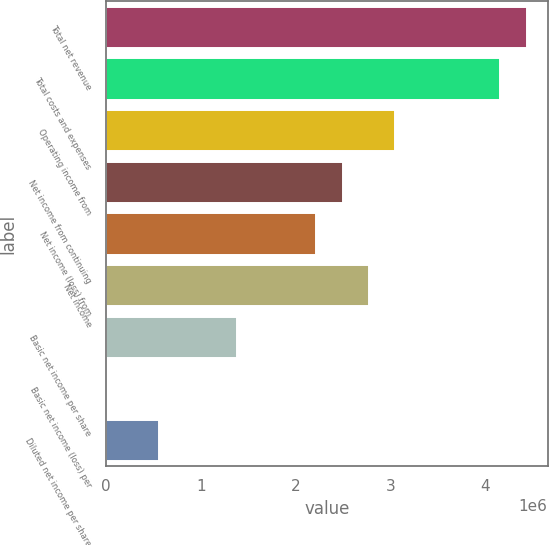Convert chart. <chart><loc_0><loc_0><loc_500><loc_500><bar_chart><fcel>Total net revenue<fcel>Total costs and expenses<fcel>Operating income from<fcel>Net income from continuing<fcel>Net income (loss) from<fcel>Net income<fcel>Basic net income per share<fcel>Basic net income (loss) per<fcel>Diluted net income per share<nl><fcel>4.43204e+06<fcel>4.15504e+06<fcel>3.04703e+06<fcel>2.49302e+06<fcel>2.21602e+06<fcel>2.77003e+06<fcel>1.38501e+06<fcel>0.11<fcel>554005<nl></chart> 